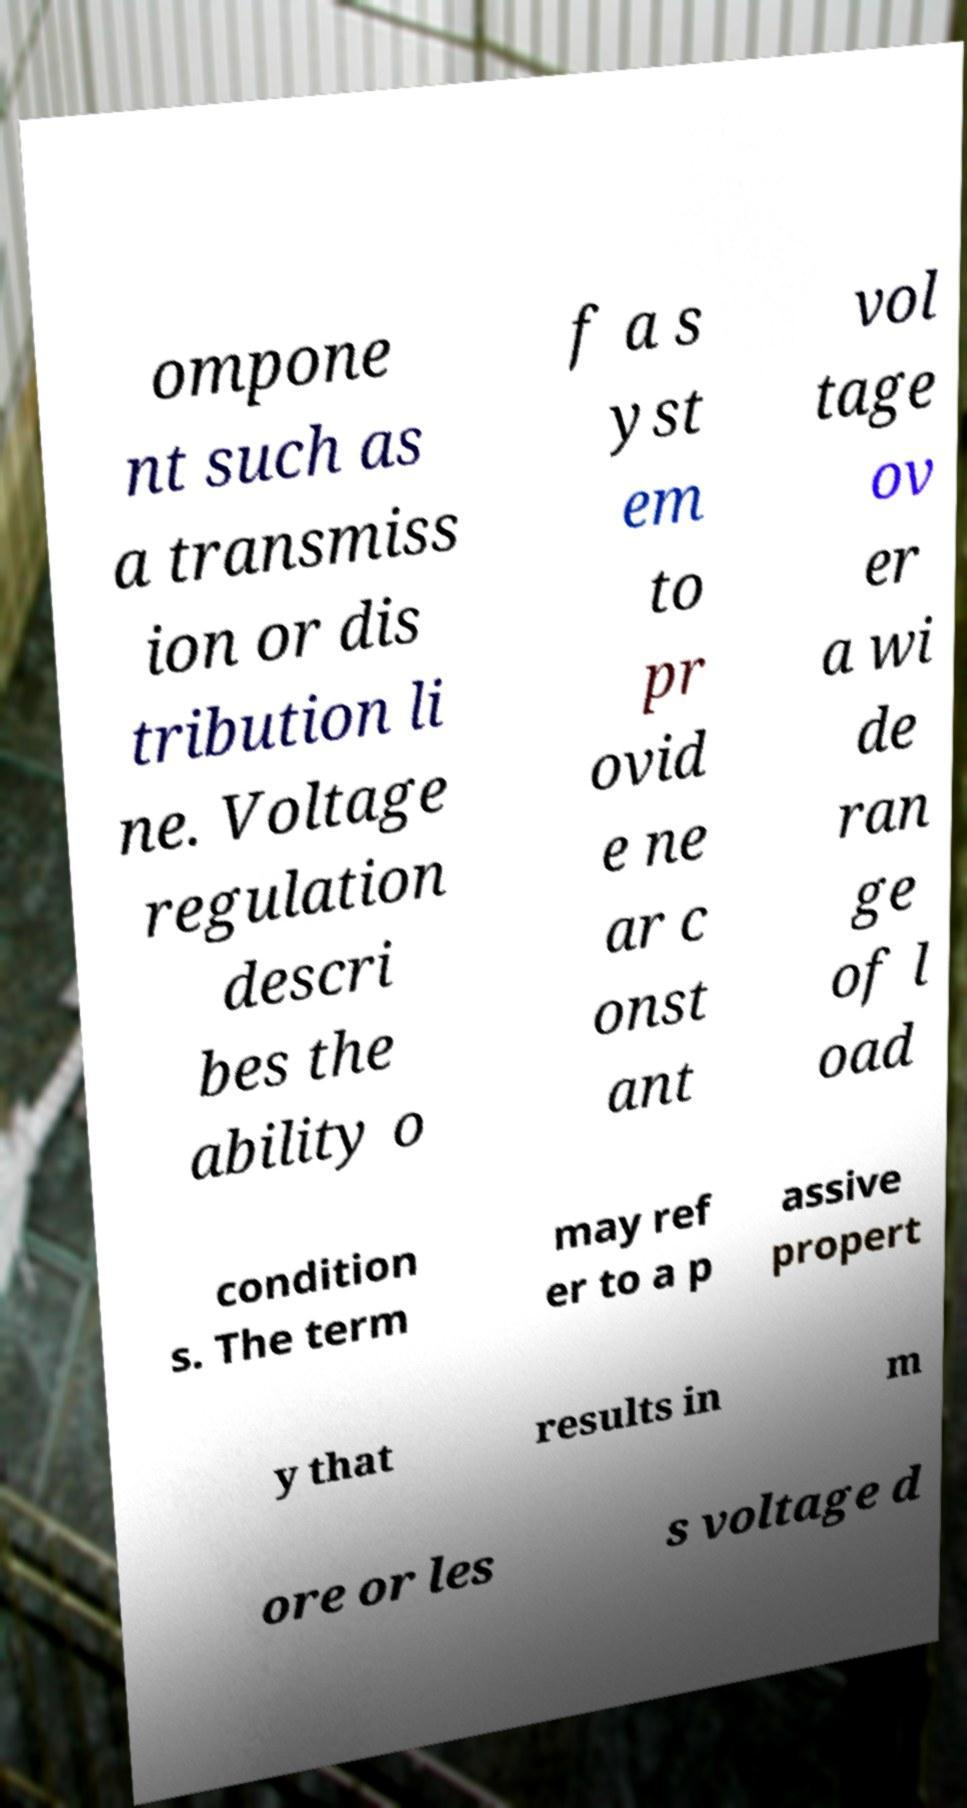Can you accurately transcribe the text from the provided image for me? ompone nt such as a transmiss ion or dis tribution li ne. Voltage regulation descri bes the ability o f a s yst em to pr ovid e ne ar c onst ant vol tage ov er a wi de ran ge of l oad condition s. The term may ref er to a p assive propert y that results in m ore or les s voltage d 